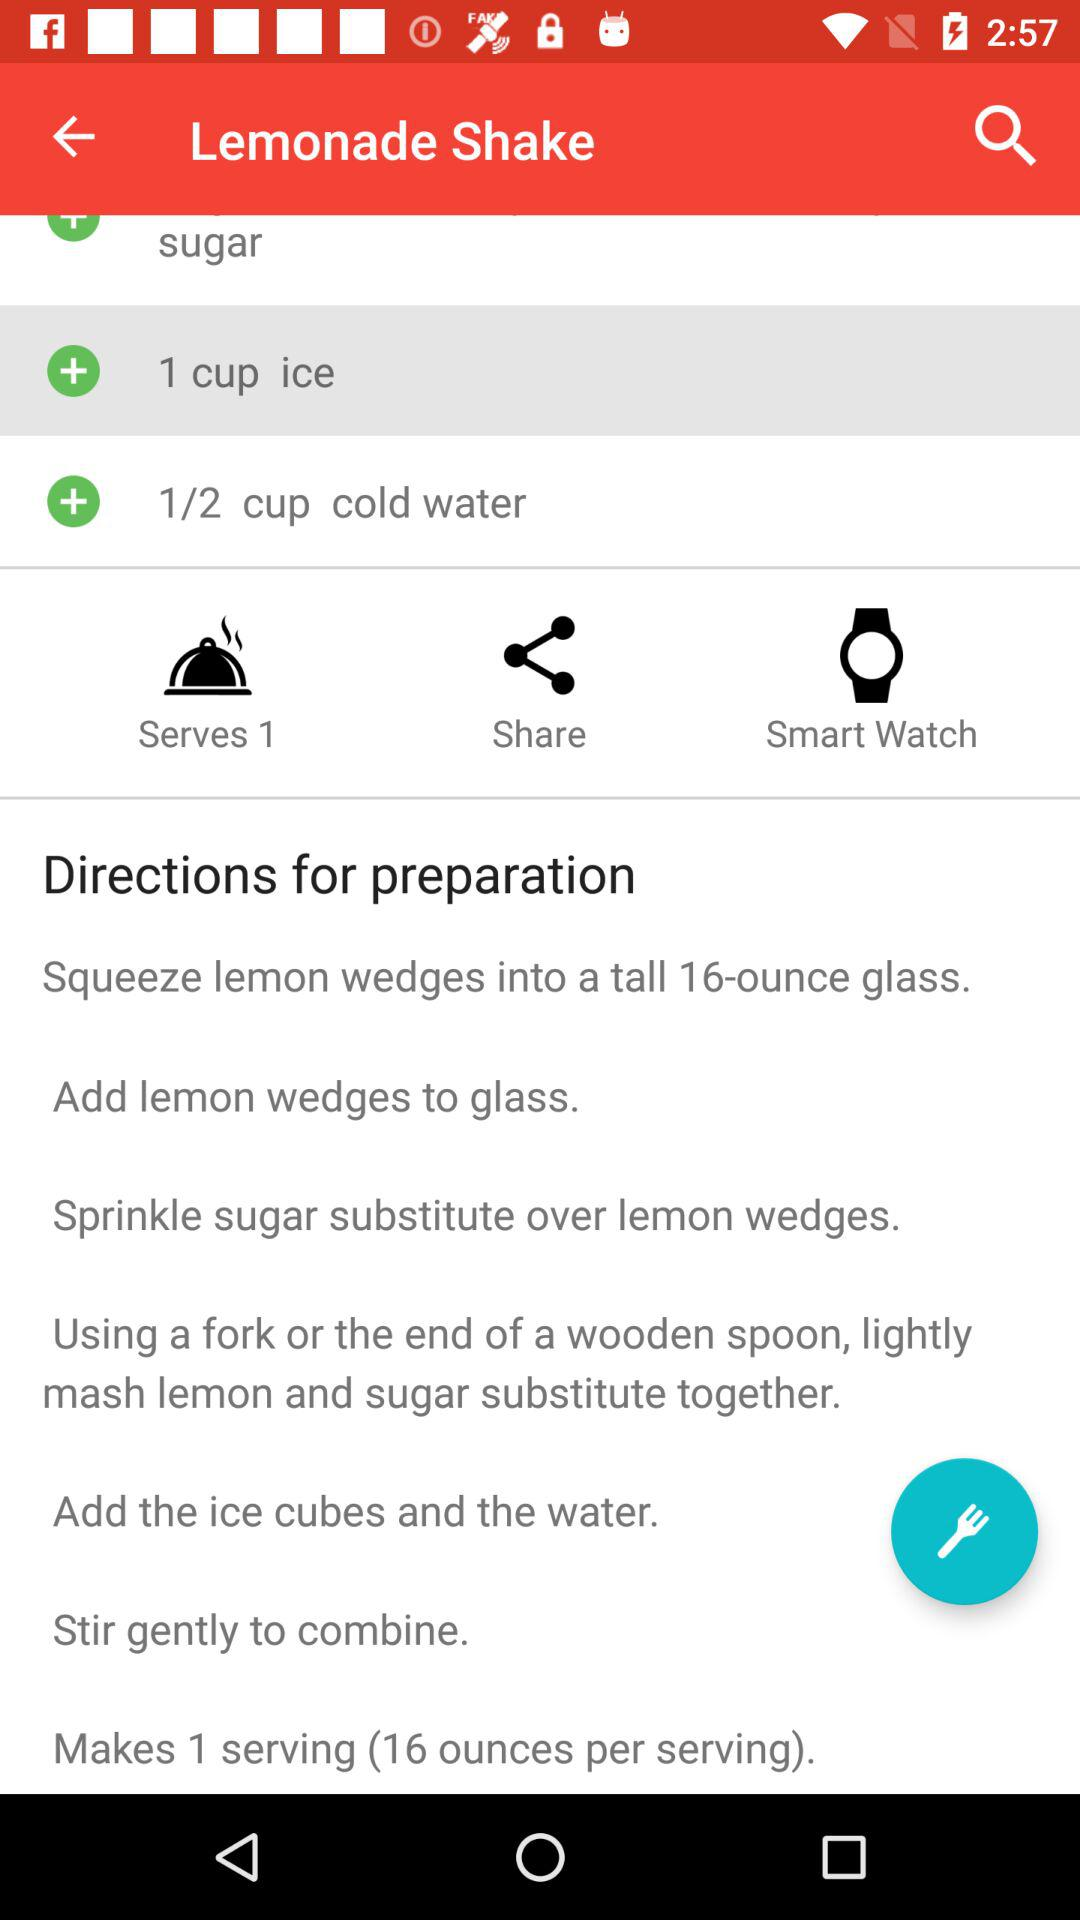How many people can I serve a "Lemonade Shake"? You can serve a "Lemonade Shake" to 1 person. 